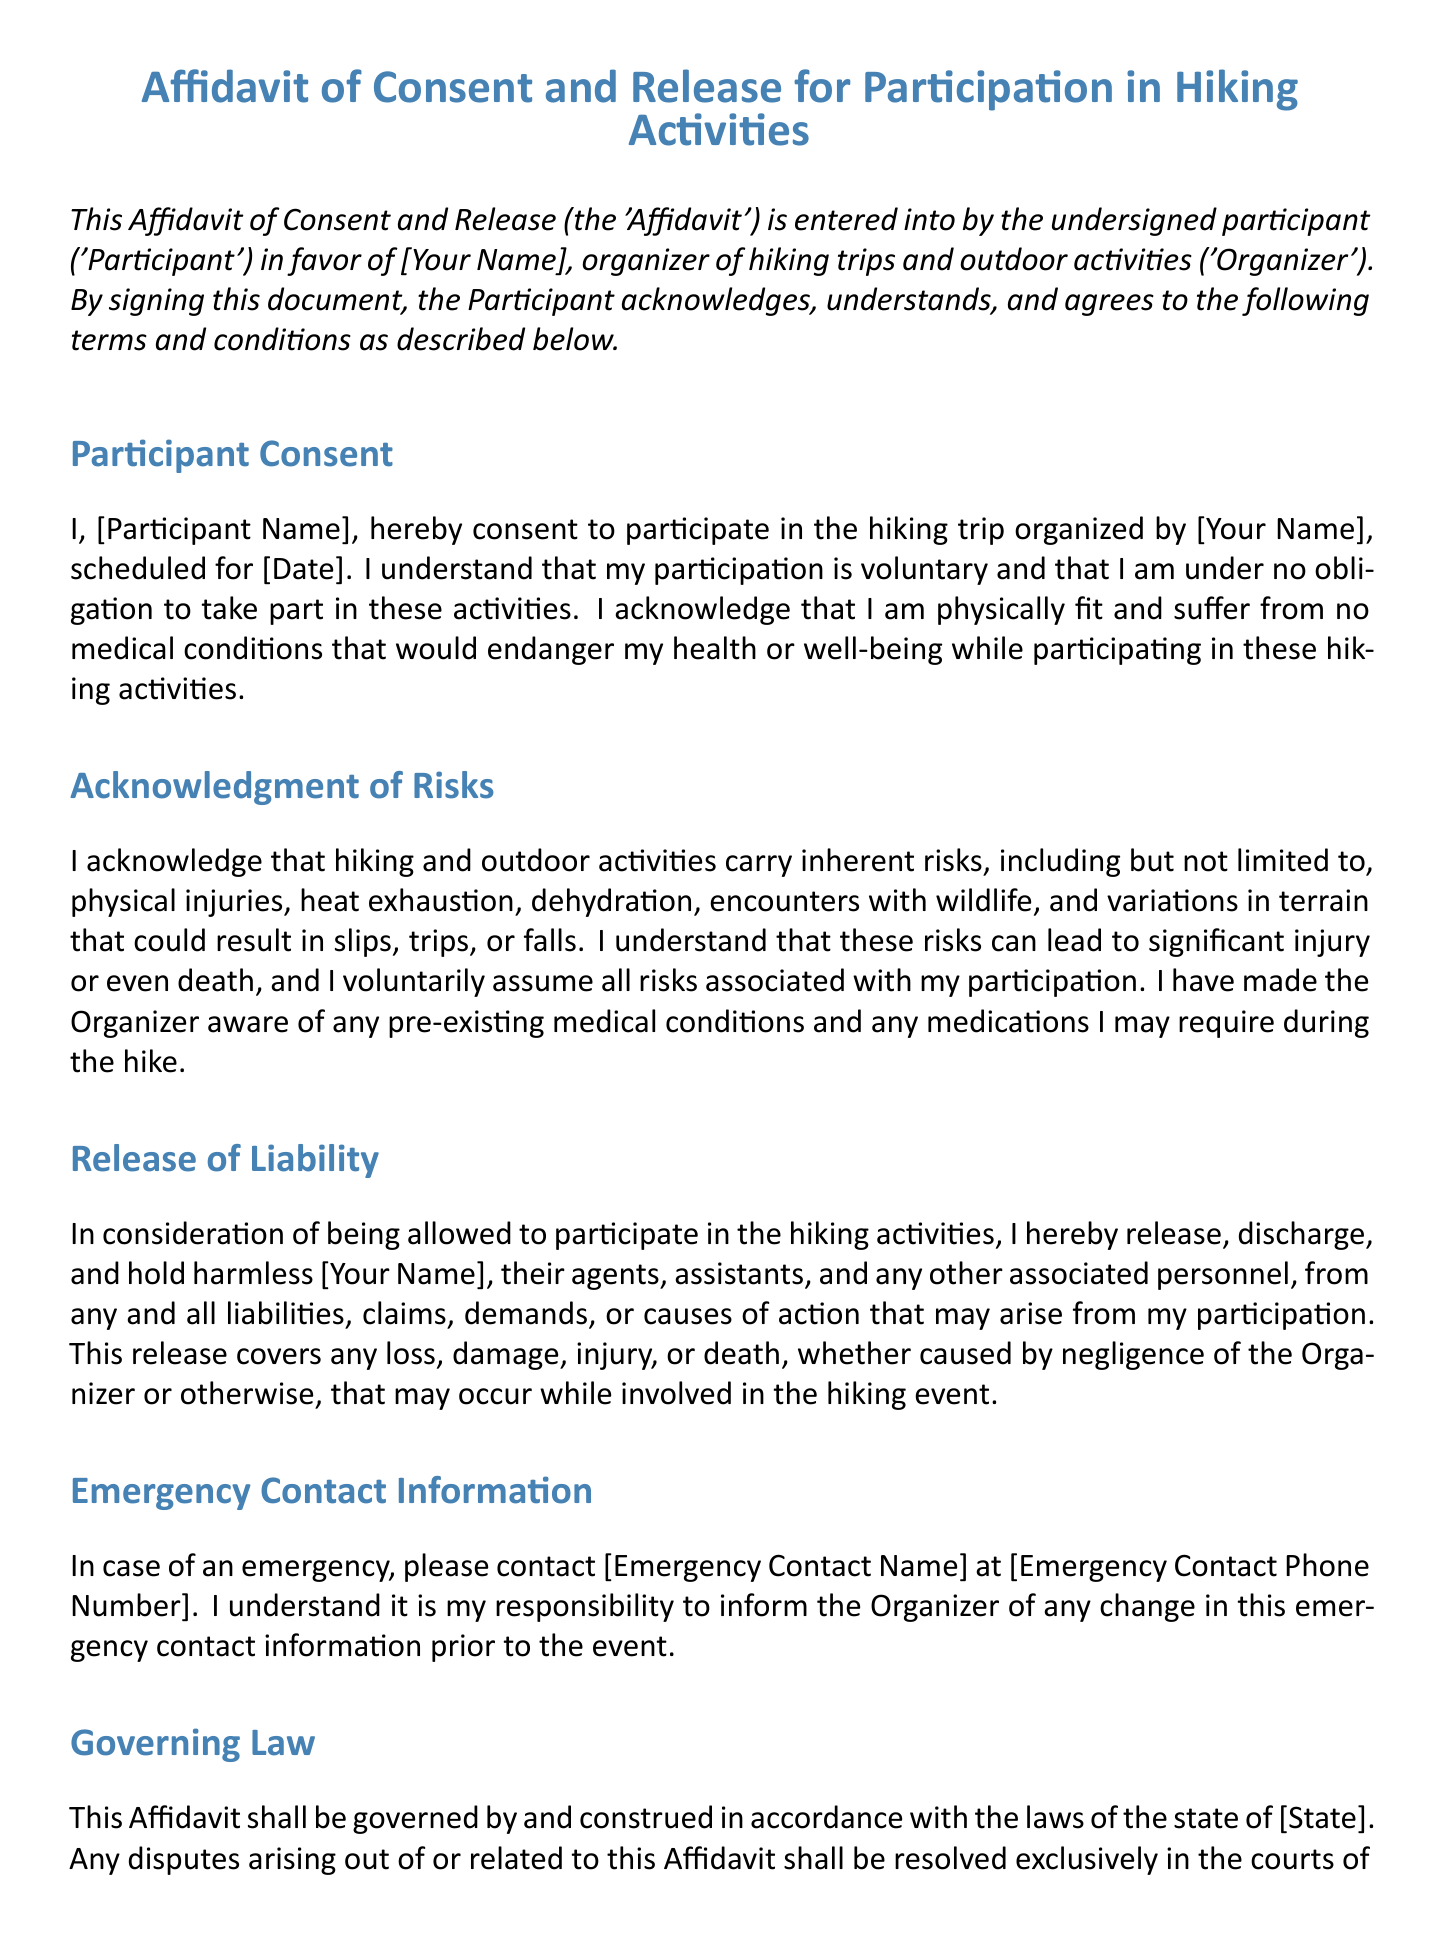what is the title of the document? The title is found at the top of the document, summarizing its purpose.
Answer: Affidavit of Consent and Release for Participation in Hiking Activities who is the organizer of the hiking trip? The organizer's name is mentioned in the document as the person in favor of whom the affidavit is made.
Answer: [Your Name] what is the scheduled date for the hiking trip? The date of the hiking trip is specified in the participant consent section of the document.
Answer: [Date] what inherent risks are acknowledged by the participant? The risks associated with hiking activities are listed in the acknowledgment of risks section.
Answer: physical injuries, heat exhaustion, dehydration, encounters with wildlife, and variations in terrain what does the participant release the organizer from? This pertains to the liabilities covered in the release of liability section of the document.
Answer: any and all liabilities, claims, demands, or causes of action what must the participant provide in case of an emergency? The document specifies the information required in case of an emergency contact situation.
Answer: Emergency Contact Information how is the affidavit governed legally? The document states the governing law that applies to the affidavit.
Answer: the laws of the state of [State] what does the participant acknowledge by signing the affidavit? This refers to the agreement and understanding of the document's terms.
Answer: that I have read and fully understand the terms of this Affidavit who must be contacted in case of an emergency? This is specified in the section related to emergency contact information in the document.
Answer: [Emergency Contact Name] 